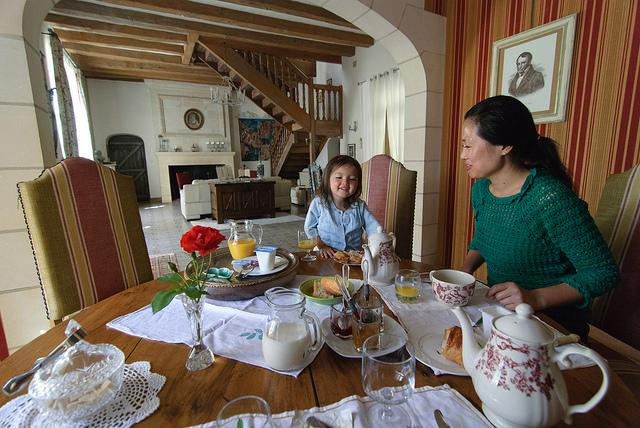Where does porcelain originally come from? Please explain your reasoning. china. Porcelain slowly evolved in china until about 2,000 years ago, when it was deemed to be a functional and beautiful addition to people's lives. today, of course, porcelain is produced internationally, and in great abundance. 